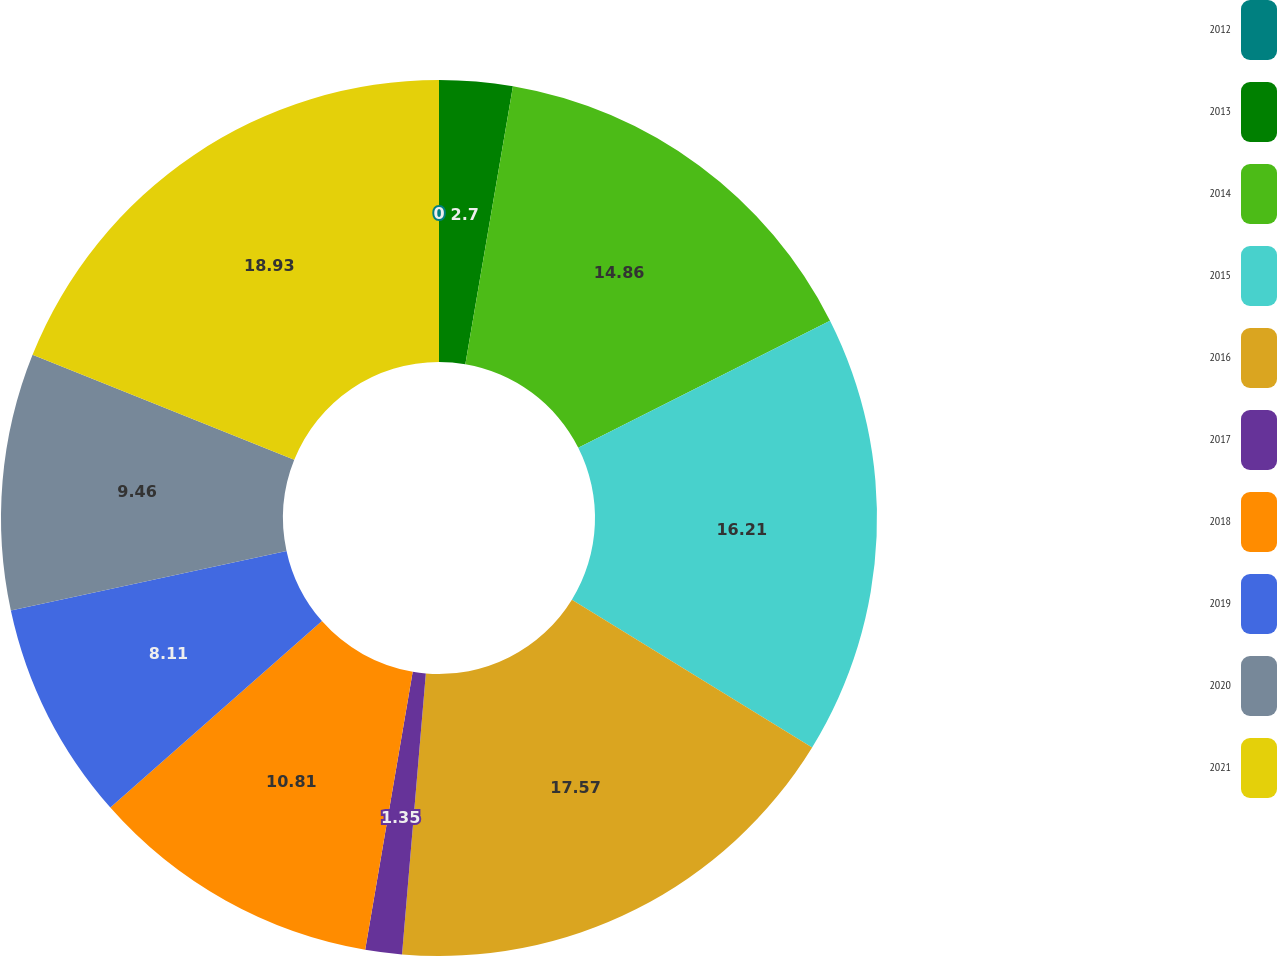<chart> <loc_0><loc_0><loc_500><loc_500><pie_chart><fcel>2012<fcel>2013<fcel>2014<fcel>2015<fcel>2016<fcel>2017<fcel>2018<fcel>2019<fcel>2020<fcel>2021<nl><fcel>0.0%<fcel>2.7%<fcel>14.86%<fcel>16.21%<fcel>17.57%<fcel>1.35%<fcel>10.81%<fcel>8.11%<fcel>9.46%<fcel>18.92%<nl></chart> 